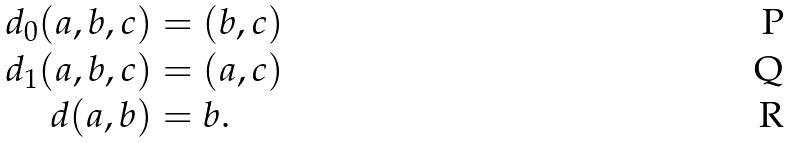Convert formula to latex. <formula><loc_0><loc_0><loc_500><loc_500>d _ { 0 } ( a , b , c ) & = ( b , c ) \\ d _ { 1 } ( a , b , c ) & = ( a , c ) \\ d ( a , b ) & = b .</formula> 